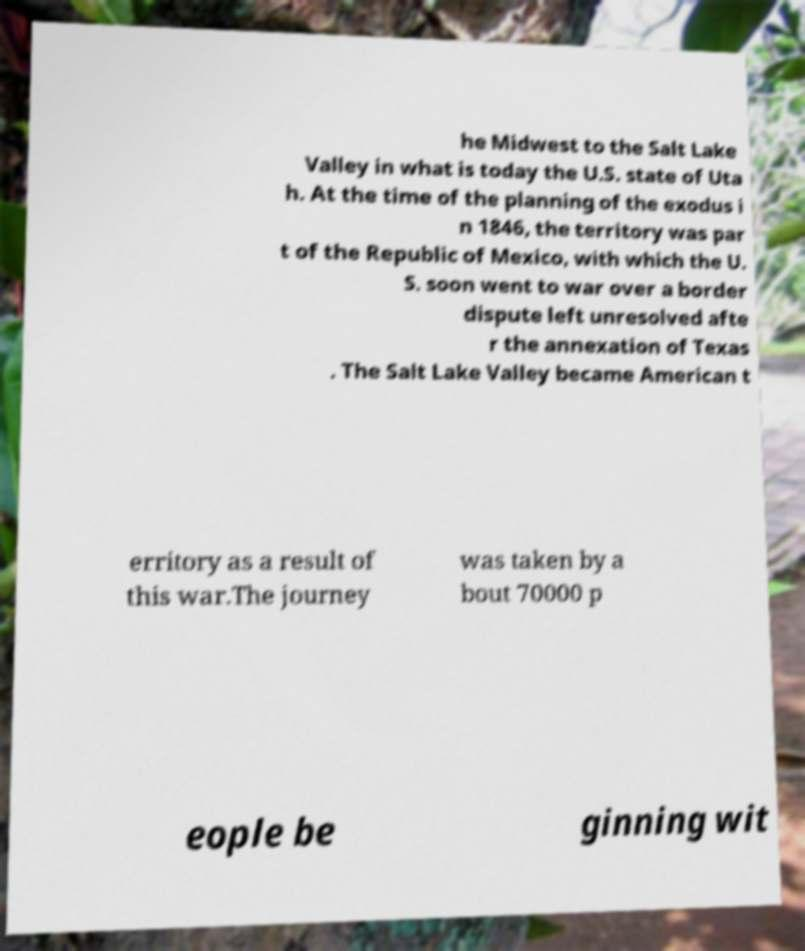Could you assist in decoding the text presented in this image and type it out clearly? he Midwest to the Salt Lake Valley in what is today the U.S. state of Uta h. At the time of the planning of the exodus i n 1846, the territory was par t of the Republic of Mexico, with which the U. S. soon went to war over a border dispute left unresolved afte r the annexation of Texas . The Salt Lake Valley became American t erritory as a result of this war.The journey was taken by a bout 70000 p eople be ginning wit 